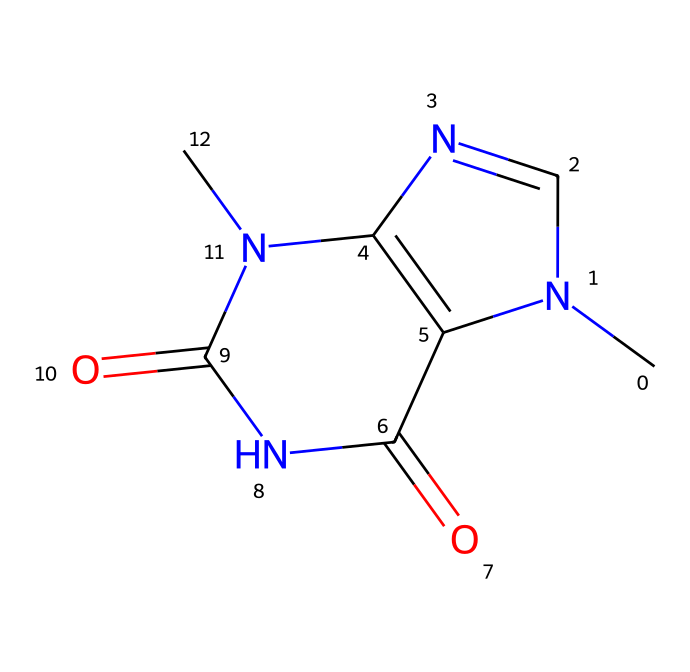What is the name of this compound? The structural formula corresponds to theobromine, a well-known alkaloid found in chocolate.
Answer: theobromine How many nitrogen atoms are in the structure? By examining the SMILES representation, we can count four nitrogen atoms (N) present in the formula.
Answer: four What is the primary functional group in this chemical? The presence of the carbonyl groups (C=O) indicates that this compound contains amide functional groups primarily.
Answer: amide How many rings are present in the structure? Analyzing the structure reveals there are two fused rings in the chemical, characteristic of many alkaloids.
Answer: two What properties does theobromine have related to its alkalinity? This alkaloid is known for being a mild stimulant, similar to caffeine, due to its nitrogen content in its structure.
Answer: stimulant What impact does this structure have on its taste? The nitrogen atoms in the structure confer a bitter taste, which is a common characteristic of many alkaloids, including theobromine.
Answer: bitter 